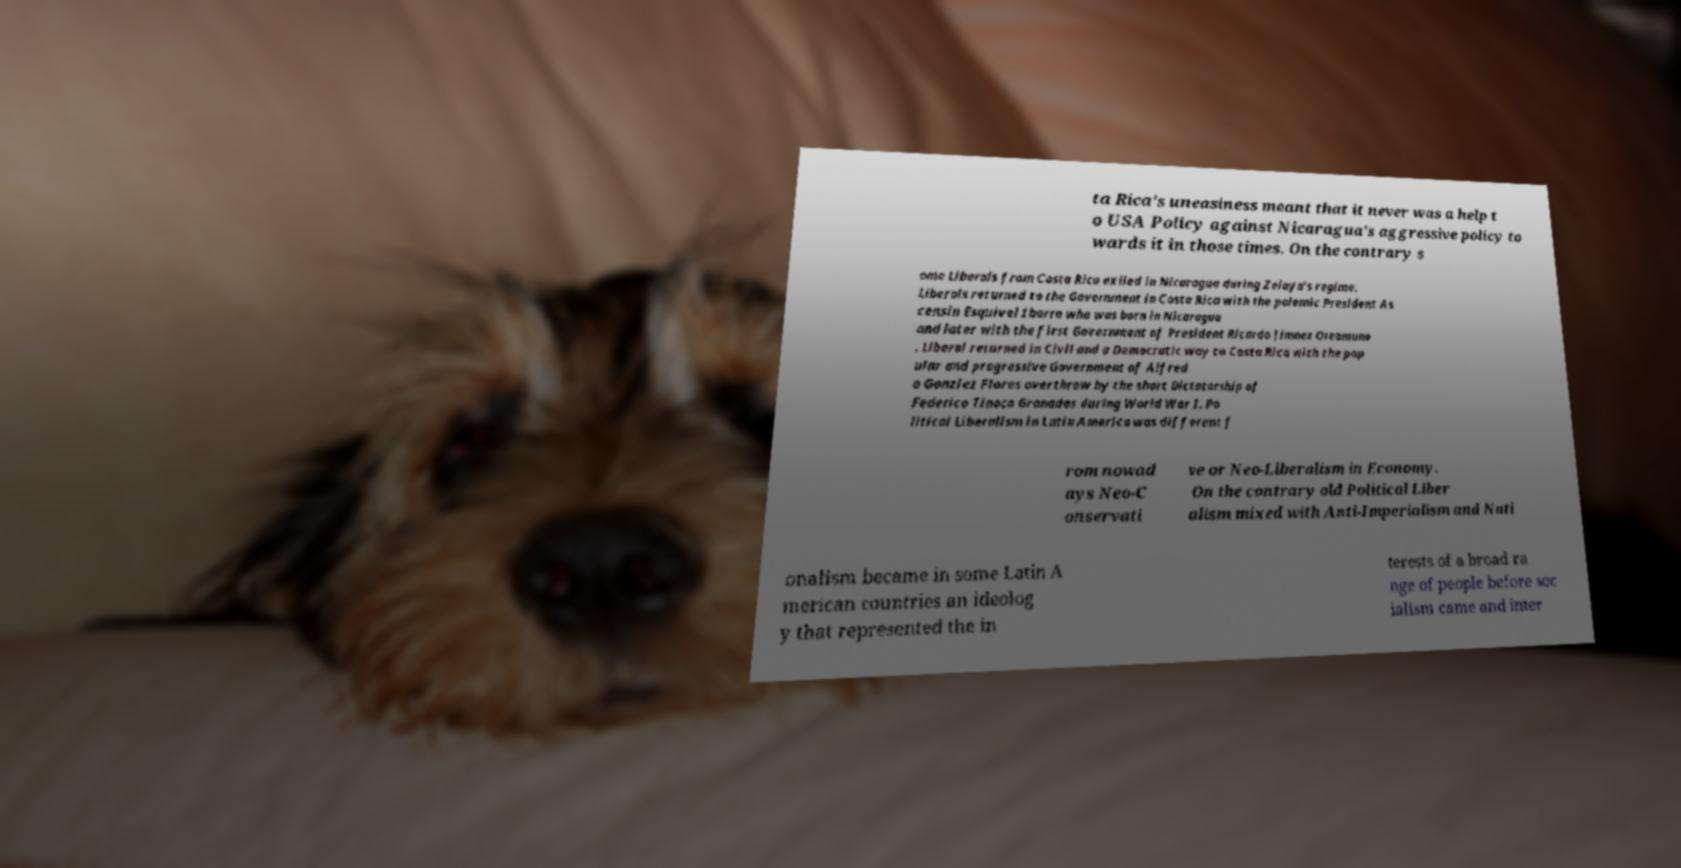Can you read and provide the text displayed in the image?This photo seems to have some interesting text. Can you extract and type it out for me? ta Rica’s uneasiness meant that it never was a help t o USA Policy against Nicaragua’s aggressive policy to wards it in those times. On the contrary s ome Liberals from Costa Rica exiled in Nicaragua during Zelaya's regime. Liberals returned to the Government in Costa Rica with the polemic President As censin Esquivel Ibarra who was born in Nicaragua and later with the first Government of President Ricardo Jimnez Oreamuno . Liberal returned in Civil and a Democratic way to Costa Rica with the pop ular and progressive Government of Alfred o Gonzlez Flores overthrow by the short Dictatorship of Federico Tinoco Granados during World War I. Po litical Liberalism in Latin America was different f rom nowad ays Neo-C onservati ve or Neo-Liberalism in Economy. On the contrary old Political Liber alism mixed with Anti-Imperialism and Nati onalism became in some Latin A merican countries an ideolog y that represented the in terests of a broad ra nge of people before soc ialism came and inter 